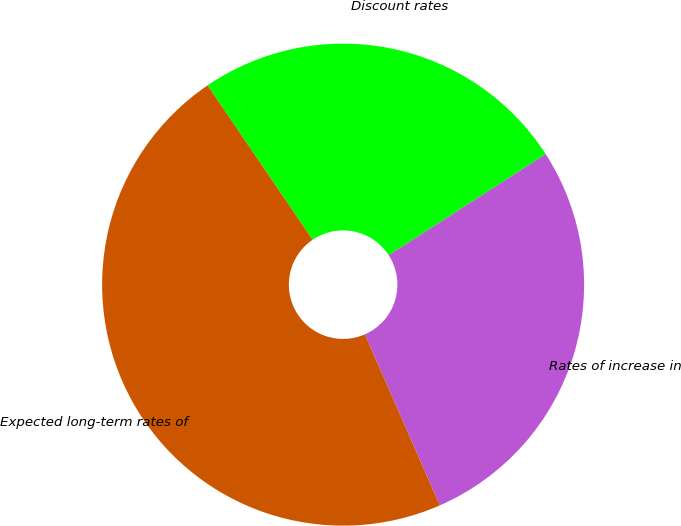Convert chart to OTSL. <chart><loc_0><loc_0><loc_500><loc_500><pie_chart><fcel>Discount rates<fcel>Rates of increase in<fcel>Expected long-term rates of<nl><fcel>25.4%<fcel>27.54%<fcel>47.06%<nl></chart> 